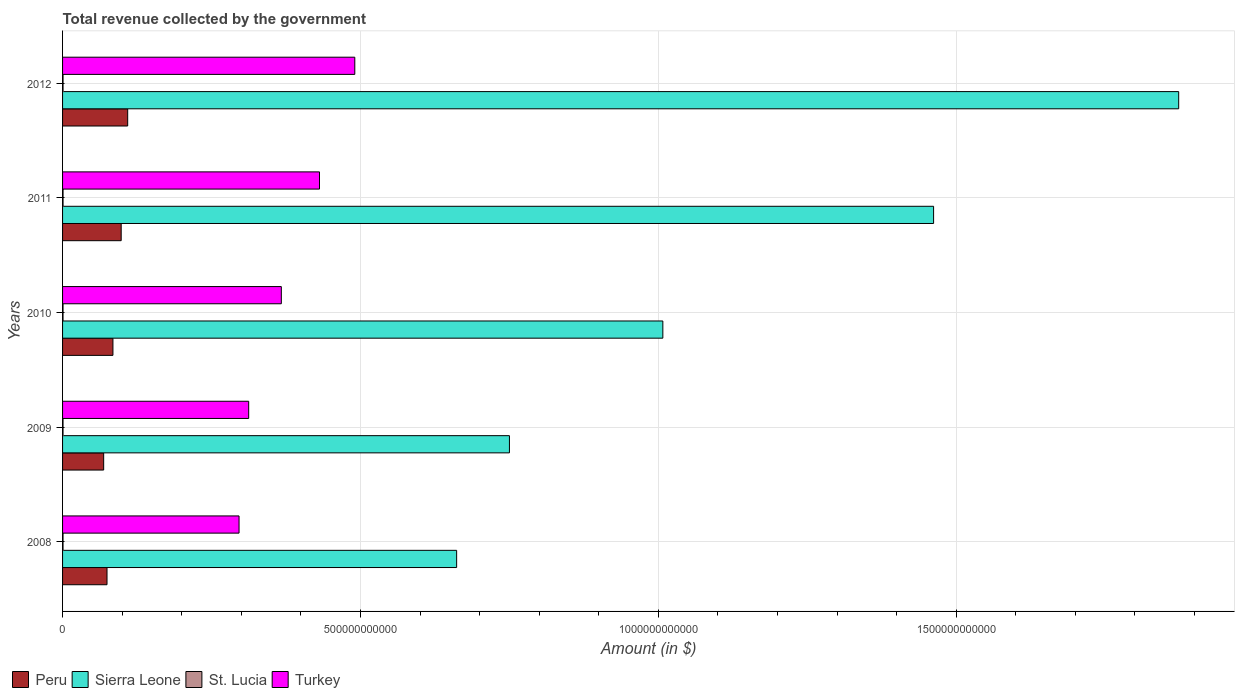How many groups of bars are there?
Your answer should be very brief. 5. Are the number of bars per tick equal to the number of legend labels?
Offer a terse response. Yes. Are the number of bars on each tick of the Y-axis equal?
Give a very brief answer. Yes. How many bars are there on the 4th tick from the top?
Offer a very short reply. 4. What is the label of the 4th group of bars from the top?
Provide a succinct answer. 2009. What is the total revenue collected by the government in Sierra Leone in 2011?
Your answer should be compact. 1.46e+12. Across all years, what is the maximum total revenue collected by the government in St. Lucia?
Make the answer very short. 8.17e+08. Across all years, what is the minimum total revenue collected by the government in Sierra Leone?
Offer a terse response. 6.61e+11. In which year was the total revenue collected by the government in Peru minimum?
Give a very brief answer. 2009. What is the total total revenue collected by the government in Sierra Leone in the graph?
Your answer should be compact. 5.75e+12. What is the difference between the total revenue collected by the government in Sierra Leone in 2008 and that in 2011?
Offer a terse response. -8.01e+11. What is the difference between the total revenue collected by the government in Turkey in 2010 and the total revenue collected by the government in Sierra Leone in 2008?
Give a very brief answer. -2.94e+11. What is the average total revenue collected by the government in Peru per year?
Offer a terse response. 8.72e+1. In the year 2008, what is the difference between the total revenue collected by the government in St. Lucia and total revenue collected by the government in Turkey?
Your answer should be compact. -2.95e+11. What is the ratio of the total revenue collected by the government in Peru in 2009 to that in 2011?
Ensure brevity in your answer.  0.7. Is the difference between the total revenue collected by the government in St. Lucia in 2009 and 2011 greater than the difference between the total revenue collected by the government in Turkey in 2009 and 2011?
Ensure brevity in your answer.  Yes. What is the difference between the highest and the second highest total revenue collected by the government in Peru?
Give a very brief answer. 1.09e+1. What is the difference between the highest and the lowest total revenue collected by the government in Peru?
Provide a short and direct response. 4.03e+1. What does the 3rd bar from the top in 2010 represents?
Offer a very short reply. Sierra Leone. How many bars are there?
Your answer should be very brief. 20. How many years are there in the graph?
Give a very brief answer. 5. What is the difference between two consecutive major ticks on the X-axis?
Provide a succinct answer. 5.00e+11. Does the graph contain any zero values?
Your response must be concise. No. Where does the legend appear in the graph?
Offer a very short reply. Bottom left. What is the title of the graph?
Offer a terse response. Total revenue collected by the government. Does "Vietnam" appear as one of the legend labels in the graph?
Provide a short and direct response. No. What is the label or title of the X-axis?
Provide a short and direct response. Amount (in $). What is the label or title of the Y-axis?
Your answer should be compact. Years. What is the Amount (in $) in Peru in 2008?
Provide a succinct answer. 7.46e+1. What is the Amount (in $) in Sierra Leone in 2008?
Keep it short and to the point. 6.61e+11. What is the Amount (in $) of St. Lucia in 2008?
Provide a succinct answer. 7.81e+08. What is the Amount (in $) of Turkey in 2008?
Provide a short and direct response. 2.96e+11. What is the Amount (in $) of Peru in 2009?
Your answer should be very brief. 6.90e+1. What is the Amount (in $) in Sierra Leone in 2009?
Make the answer very short. 7.50e+11. What is the Amount (in $) in St. Lucia in 2009?
Offer a terse response. 7.71e+08. What is the Amount (in $) of Turkey in 2009?
Offer a very short reply. 3.12e+11. What is the Amount (in $) of Peru in 2010?
Provide a short and direct response. 8.45e+1. What is the Amount (in $) of Sierra Leone in 2010?
Your response must be concise. 1.01e+12. What is the Amount (in $) of St. Lucia in 2010?
Give a very brief answer. 7.76e+08. What is the Amount (in $) in Turkey in 2010?
Make the answer very short. 3.67e+11. What is the Amount (in $) in Peru in 2011?
Ensure brevity in your answer.  9.84e+1. What is the Amount (in $) of Sierra Leone in 2011?
Your answer should be very brief. 1.46e+12. What is the Amount (in $) in St. Lucia in 2011?
Ensure brevity in your answer.  8.17e+08. What is the Amount (in $) of Turkey in 2011?
Provide a short and direct response. 4.31e+11. What is the Amount (in $) of Peru in 2012?
Keep it short and to the point. 1.09e+11. What is the Amount (in $) of Sierra Leone in 2012?
Your response must be concise. 1.87e+12. What is the Amount (in $) of St. Lucia in 2012?
Your response must be concise. 8.10e+08. What is the Amount (in $) of Turkey in 2012?
Offer a terse response. 4.91e+11. Across all years, what is the maximum Amount (in $) in Peru?
Ensure brevity in your answer.  1.09e+11. Across all years, what is the maximum Amount (in $) of Sierra Leone?
Give a very brief answer. 1.87e+12. Across all years, what is the maximum Amount (in $) in St. Lucia?
Give a very brief answer. 8.17e+08. Across all years, what is the maximum Amount (in $) of Turkey?
Ensure brevity in your answer.  4.91e+11. Across all years, what is the minimum Amount (in $) of Peru?
Ensure brevity in your answer.  6.90e+1. Across all years, what is the minimum Amount (in $) of Sierra Leone?
Ensure brevity in your answer.  6.61e+11. Across all years, what is the minimum Amount (in $) of St. Lucia?
Provide a succinct answer. 7.71e+08. Across all years, what is the minimum Amount (in $) in Turkey?
Keep it short and to the point. 2.96e+11. What is the total Amount (in $) in Peru in the graph?
Offer a very short reply. 4.36e+11. What is the total Amount (in $) of Sierra Leone in the graph?
Your answer should be very brief. 5.75e+12. What is the total Amount (in $) of St. Lucia in the graph?
Keep it short and to the point. 3.96e+09. What is the total Amount (in $) of Turkey in the graph?
Offer a terse response. 1.90e+12. What is the difference between the Amount (in $) of Peru in 2008 and that in 2009?
Ensure brevity in your answer.  5.60e+09. What is the difference between the Amount (in $) in Sierra Leone in 2008 and that in 2009?
Make the answer very short. -8.86e+1. What is the difference between the Amount (in $) in St. Lucia in 2008 and that in 2009?
Your response must be concise. 1.03e+07. What is the difference between the Amount (in $) of Turkey in 2008 and that in 2009?
Keep it short and to the point. -1.62e+1. What is the difference between the Amount (in $) of Peru in 2008 and that in 2010?
Your answer should be very brief. -9.94e+09. What is the difference between the Amount (in $) of Sierra Leone in 2008 and that in 2010?
Keep it short and to the point. -3.46e+11. What is the difference between the Amount (in $) of St. Lucia in 2008 and that in 2010?
Make the answer very short. 4.90e+06. What is the difference between the Amount (in $) in Turkey in 2008 and that in 2010?
Give a very brief answer. -7.10e+1. What is the difference between the Amount (in $) of Peru in 2008 and that in 2011?
Ensure brevity in your answer.  -2.38e+1. What is the difference between the Amount (in $) of Sierra Leone in 2008 and that in 2011?
Make the answer very short. -8.01e+11. What is the difference between the Amount (in $) of St. Lucia in 2008 and that in 2011?
Offer a very short reply. -3.54e+07. What is the difference between the Amount (in $) of Turkey in 2008 and that in 2011?
Give a very brief answer. -1.35e+11. What is the difference between the Amount (in $) of Peru in 2008 and that in 2012?
Offer a terse response. -3.47e+1. What is the difference between the Amount (in $) in Sierra Leone in 2008 and that in 2012?
Ensure brevity in your answer.  -1.21e+12. What is the difference between the Amount (in $) of St. Lucia in 2008 and that in 2012?
Your response must be concise. -2.92e+07. What is the difference between the Amount (in $) in Turkey in 2008 and that in 2012?
Ensure brevity in your answer.  -1.94e+11. What is the difference between the Amount (in $) of Peru in 2009 and that in 2010?
Offer a terse response. -1.55e+1. What is the difference between the Amount (in $) of Sierra Leone in 2009 and that in 2010?
Make the answer very short. -2.58e+11. What is the difference between the Amount (in $) in St. Lucia in 2009 and that in 2010?
Ensure brevity in your answer.  -5.40e+06. What is the difference between the Amount (in $) in Turkey in 2009 and that in 2010?
Make the answer very short. -5.48e+1. What is the difference between the Amount (in $) of Peru in 2009 and that in 2011?
Give a very brief answer. -2.94e+1. What is the difference between the Amount (in $) of Sierra Leone in 2009 and that in 2011?
Your answer should be very brief. -7.12e+11. What is the difference between the Amount (in $) of St. Lucia in 2009 and that in 2011?
Make the answer very short. -4.57e+07. What is the difference between the Amount (in $) of Turkey in 2009 and that in 2011?
Your answer should be compact. -1.19e+11. What is the difference between the Amount (in $) in Peru in 2009 and that in 2012?
Provide a short and direct response. -4.03e+1. What is the difference between the Amount (in $) of Sierra Leone in 2009 and that in 2012?
Keep it short and to the point. -1.12e+12. What is the difference between the Amount (in $) of St. Lucia in 2009 and that in 2012?
Make the answer very short. -3.95e+07. What is the difference between the Amount (in $) in Turkey in 2009 and that in 2012?
Offer a very short reply. -1.78e+11. What is the difference between the Amount (in $) of Peru in 2010 and that in 2011?
Provide a succinct answer. -1.39e+1. What is the difference between the Amount (in $) in Sierra Leone in 2010 and that in 2011?
Offer a terse response. -4.54e+11. What is the difference between the Amount (in $) in St. Lucia in 2010 and that in 2011?
Ensure brevity in your answer.  -4.03e+07. What is the difference between the Amount (in $) of Turkey in 2010 and that in 2011?
Ensure brevity in your answer.  -6.41e+1. What is the difference between the Amount (in $) in Peru in 2010 and that in 2012?
Ensure brevity in your answer.  -2.48e+1. What is the difference between the Amount (in $) in Sierra Leone in 2010 and that in 2012?
Provide a short and direct response. -8.66e+11. What is the difference between the Amount (in $) in St. Lucia in 2010 and that in 2012?
Provide a short and direct response. -3.41e+07. What is the difference between the Amount (in $) of Turkey in 2010 and that in 2012?
Provide a succinct answer. -1.23e+11. What is the difference between the Amount (in $) in Peru in 2011 and that in 2012?
Offer a terse response. -1.09e+1. What is the difference between the Amount (in $) in Sierra Leone in 2011 and that in 2012?
Provide a succinct answer. -4.11e+11. What is the difference between the Amount (in $) of St. Lucia in 2011 and that in 2012?
Ensure brevity in your answer.  6.20e+06. What is the difference between the Amount (in $) of Turkey in 2011 and that in 2012?
Keep it short and to the point. -5.93e+1. What is the difference between the Amount (in $) of Peru in 2008 and the Amount (in $) of Sierra Leone in 2009?
Provide a succinct answer. -6.76e+11. What is the difference between the Amount (in $) in Peru in 2008 and the Amount (in $) in St. Lucia in 2009?
Your response must be concise. 7.38e+1. What is the difference between the Amount (in $) of Peru in 2008 and the Amount (in $) of Turkey in 2009?
Your answer should be compact. -2.38e+11. What is the difference between the Amount (in $) in Sierra Leone in 2008 and the Amount (in $) in St. Lucia in 2009?
Offer a very short reply. 6.61e+11. What is the difference between the Amount (in $) in Sierra Leone in 2008 and the Amount (in $) in Turkey in 2009?
Your answer should be compact. 3.49e+11. What is the difference between the Amount (in $) of St. Lucia in 2008 and the Amount (in $) of Turkey in 2009?
Ensure brevity in your answer.  -3.12e+11. What is the difference between the Amount (in $) of Peru in 2008 and the Amount (in $) of Sierra Leone in 2010?
Your answer should be compact. -9.33e+11. What is the difference between the Amount (in $) of Peru in 2008 and the Amount (in $) of St. Lucia in 2010?
Make the answer very short. 7.38e+1. What is the difference between the Amount (in $) of Peru in 2008 and the Amount (in $) of Turkey in 2010?
Keep it short and to the point. -2.93e+11. What is the difference between the Amount (in $) of Sierra Leone in 2008 and the Amount (in $) of St. Lucia in 2010?
Provide a succinct answer. 6.61e+11. What is the difference between the Amount (in $) in Sierra Leone in 2008 and the Amount (in $) in Turkey in 2010?
Ensure brevity in your answer.  2.94e+11. What is the difference between the Amount (in $) in St. Lucia in 2008 and the Amount (in $) in Turkey in 2010?
Make the answer very short. -3.66e+11. What is the difference between the Amount (in $) of Peru in 2008 and the Amount (in $) of Sierra Leone in 2011?
Your answer should be very brief. -1.39e+12. What is the difference between the Amount (in $) of Peru in 2008 and the Amount (in $) of St. Lucia in 2011?
Your answer should be compact. 7.38e+1. What is the difference between the Amount (in $) of Peru in 2008 and the Amount (in $) of Turkey in 2011?
Offer a very short reply. -3.57e+11. What is the difference between the Amount (in $) of Sierra Leone in 2008 and the Amount (in $) of St. Lucia in 2011?
Provide a succinct answer. 6.61e+11. What is the difference between the Amount (in $) in Sierra Leone in 2008 and the Amount (in $) in Turkey in 2011?
Your response must be concise. 2.30e+11. What is the difference between the Amount (in $) of St. Lucia in 2008 and the Amount (in $) of Turkey in 2011?
Offer a terse response. -4.31e+11. What is the difference between the Amount (in $) in Peru in 2008 and the Amount (in $) in Sierra Leone in 2012?
Give a very brief answer. -1.80e+12. What is the difference between the Amount (in $) in Peru in 2008 and the Amount (in $) in St. Lucia in 2012?
Your answer should be compact. 7.38e+1. What is the difference between the Amount (in $) of Peru in 2008 and the Amount (in $) of Turkey in 2012?
Offer a terse response. -4.16e+11. What is the difference between the Amount (in $) in Sierra Leone in 2008 and the Amount (in $) in St. Lucia in 2012?
Ensure brevity in your answer.  6.61e+11. What is the difference between the Amount (in $) in Sierra Leone in 2008 and the Amount (in $) in Turkey in 2012?
Make the answer very short. 1.71e+11. What is the difference between the Amount (in $) of St. Lucia in 2008 and the Amount (in $) of Turkey in 2012?
Offer a very short reply. -4.90e+11. What is the difference between the Amount (in $) of Peru in 2009 and the Amount (in $) of Sierra Leone in 2010?
Offer a very short reply. -9.39e+11. What is the difference between the Amount (in $) of Peru in 2009 and the Amount (in $) of St. Lucia in 2010?
Make the answer very short. 6.82e+1. What is the difference between the Amount (in $) in Peru in 2009 and the Amount (in $) in Turkey in 2010?
Provide a succinct answer. -2.98e+11. What is the difference between the Amount (in $) of Sierra Leone in 2009 and the Amount (in $) of St. Lucia in 2010?
Offer a very short reply. 7.49e+11. What is the difference between the Amount (in $) of Sierra Leone in 2009 and the Amount (in $) of Turkey in 2010?
Provide a short and direct response. 3.83e+11. What is the difference between the Amount (in $) of St. Lucia in 2009 and the Amount (in $) of Turkey in 2010?
Ensure brevity in your answer.  -3.66e+11. What is the difference between the Amount (in $) of Peru in 2009 and the Amount (in $) of Sierra Leone in 2011?
Make the answer very short. -1.39e+12. What is the difference between the Amount (in $) of Peru in 2009 and the Amount (in $) of St. Lucia in 2011?
Provide a succinct answer. 6.82e+1. What is the difference between the Amount (in $) of Peru in 2009 and the Amount (in $) of Turkey in 2011?
Keep it short and to the point. -3.62e+11. What is the difference between the Amount (in $) in Sierra Leone in 2009 and the Amount (in $) in St. Lucia in 2011?
Offer a terse response. 7.49e+11. What is the difference between the Amount (in $) of Sierra Leone in 2009 and the Amount (in $) of Turkey in 2011?
Ensure brevity in your answer.  3.19e+11. What is the difference between the Amount (in $) in St. Lucia in 2009 and the Amount (in $) in Turkey in 2011?
Keep it short and to the point. -4.31e+11. What is the difference between the Amount (in $) in Peru in 2009 and the Amount (in $) in Sierra Leone in 2012?
Give a very brief answer. -1.80e+12. What is the difference between the Amount (in $) of Peru in 2009 and the Amount (in $) of St. Lucia in 2012?
Offer a very short reply. 6.82e+1. What is the difference between the Amount (in $) in Peru in 2009 and the Amount (in $) in Turkey in 2012?
Give a very brief answer. -4.22e+11. What is the difference between the Amount (in $) in Sierra Leone in 2009 and the Amount (in $) in St. Lucia in 2012?
Offer a terse response. 7.49e+11. What is the difference between the Amount (in $) of Sierra Leone in 2009 and the Amount (in $) of Turkey in 2012?
Give a very brief answer. 2.60e+11. What is the difference between the Amount (in $) in St. Lucia in 2009 and the Amount (in $) in Turkey in 2012?
Your response must be concise. -4.90e+11. What is the difference between the Amount (in $) of Peru in 2010 and the Amount (in $) of Sierra Leone in 2011?
Your answer should be compact. -1.38e+12. What is the difference between the Amount (in $) of Peru in 2010 and the Amount (in $) of St. Lucia in 2011?
Your response must be concise. 8.37e+1. What is the difference between the Amount (in $) of Peru in 2010 and the Amount (in $) of Turkey in 2011?
Offer a very short reply. -3.47e+11. What is the difference between the Amount (in $) of Sierra Leone in 2010 and the Amount (in $) of St. Lucia in 2011?
Offer a terse response. 1.01e+12. What is the difference between the Amount (in $) of Sierra Leone in 2010 and the Amount (in $) of Turkey in 2011?
Provide a succinct answer. 5.76e+11. What is the difference between the Amount (in $) in St. Lucia in 2010 and the Amount (in $) in Turkey in 2011?
Offer a very short reply. -4.31e+11. What is the difference between the Amount (in $) in Peru in 2010 and the Amount (in $) in Sierra Leone in 2012?
Make the answer very short. -1.79e+12. What is the difference between the Amount (in $) in Peru in 2010 and the Amount (in $) in St. Lucia in 2012?
Your answer should be compact. 8.37e+1. What is the difference between the Amount (in $) in Peru in 2010 and the Amount (in $) in Turkey in 2012?
Your answer should be compact. -4.06e+11. What is the difference between the Amount (in $) in Sierra Leone in 2010 and the Amount (in $) in St. Lucia in 2012?
Provide a succinct answer. 1.01e+12. What is the difference between the Amount (in $) in Sierra Leone in 2010 and the Amount (in $) in Turkey in 2012?
Make the answer very short. 5.17e+11. What is the difference between the Amount (in $) in St. Lucia in 2010 and the Amount (in $) in Turkey in 2012?
Your response must be concise. -4.90e+11. What is the difference between the Amount (in $) of Peru in 2011 and the Amount (in $) of Sierra Leone in 2012?
Provide a succinct answer. -1.78e+12. What is the difference between the Amount (in $) of Peru in 2011 and the Amount (in $) of St. Lucia in 2012?
Keep it short and to the point. 9.76e+1. What is the difference between the Amount (in $) in Peru in 2011 and the Amount (in $) in Turkey in 2012?
Offer a terse response. -3.92e+11. What is the difference between the Amount (in $) in Sierra Leone in 2011 and the Amount (in $) in St. Lucia in 2012?
Your answer should be compact. 1.46e+12. What is the difference between the Amount (in $) in Sierra Leone in 2011 and the Amount (in $) in Turkey in 2012?
Your answer should be very brief. 9.72e+11. What is the difference between the Amount (in $) of St. Lucia in 2011 and the Amount (in $) of Turkey in 2012?
Provide a succinct answer. -4.90e+11. What is the average Amount (in $) in Peru per year?
Offer a terse response. 8.72e+1. What is the average Amount (in $) of Sierra Leone per year?
Your response must be concise. 1.15e+12. What is the average Amount (in $) in St. Lucia per year?
Give a very brief answer. 7.91e+08. What is the average Amount (in $) in Turkey per year?
Provide a short and direct response. 3.80e+11. In the year 2008, what is the difference between the Amount (in $) of Peru and Amount (in $) of Sierra Leone?
Ensure brevity in your answer.  -5.87e+11. In the year 2008, what is the difference between the Amount (in $) of Peru and Amount (in $) of St. Lucia?
Offer a very short reply. 7.38e+1. In the year 2008, what is the difference between the Amount (in $) in Peru and Amount (in $) in Turkey?
Offer a terse response. -2.22e+11. In the year 2008, what is the difference between the Amount (in $) of Sierra Leone and Amount (in $) of St. Lucia?
Provide a short and direct response. 6.61e+11. In the year 2008, what is the difference between the Amount (in $) in Sierra Leone and Amount (in $) in Turkey?
Offer a very short reply. 3.65e+11. In the year 2008, what is the difference between the Amount (in $) in St. Lucia and Amount (in $) in Turkey?
Offer a terse response. -2.95e+11. In the year 2009, what is the difference between the Amount (in $) in Peru and Amount (in $) in Sierra Leone?
Your response must be concise. -6.81e+11. In the year 2009, what is the difference between the Amount (in $) of Peru and Amount (in $) of St. Lucia?
Your answer should be compact. 6.82e+1. In the year 2009, what is the difference between the Amount (in $) in Peru and Amount (in $) in Turkey?
Give a very brief answer. -2.43e+11. In the year 2009, what is the difference between the Amount (in $) in Sierra Leone and Amount (in $) in St. Lucia?
Your answer should be very brief. 7.49e+11. In the year 2009, what is the difference between the Amount (in $) in Sierra Leone and Amount (in $) in Turkey?
Offer a very short reply. 4.38e+11. In the year 2009, what is the difference between the Amount (in $) in St. Lucia and Amount (in $) in Turkey?
Your answer should be very brief. -3.12e+11. In the year 2010, what is the difference between the Amount (in $) of Peru and Amount (in $) of Sierra Leone?
Offer a terse response. -9.23e+11. In the year 2010, what is the difference between the Amount (in $) in Peru and Amount (in $) in St. Lucia?
Provide a short and direct response. 8.38e+1. In the year 2010, what is the difference between the Amount (in $) in Peru and Amount (in $) in Turkey?
Make the answer very short. -2.83e+11. In the year 2010, what is the difference between the Amount (in $) of Sierra Leone and Amount (in $) of St. Lucia?
Make the answer very short. 1.01e+12. In the year 2010, what is the difference between the Amount (in $) of Sierra Leone and Amount (in $) of Turkey?
Your response must be concise. 6.40e+11. In the year 2010, what is the difference between the Amount (in $) of St. Lucia and Amount (in $) of Turkey?
Offer a very short reply. -3.66e+11. In the year 2011, what is the difference between the Amount (in $) in Peru and Amount (in $) in Sierra Leone?
Provide a short and direct response. -1.36e+12. In the year 2011, what is the difference between the Amount (in $) in Peru and Amount (in $) in St. Lucia?
Offer a terse response. 9.76e+1. In the year 2011, what is the difference between the Amount (in $) in Peru and Amount (in $) in Turkey?
Offer a very short reply. -3.33e+11. In the year 2011, what is the difference between the Amount (in $) of Sierra Leone and Amount (in $) of St. Lucia?
Provide a succinct answer. 1.46e+12. In the year 2011, what is the difference between the Amount (in $) of Sierra Leone and Amount (in $) of Turkey?
Keep it short and to the point. 1.03e+12. In the year 2011, what is the difference between the Amount (in $) in St. Lucia and Amount (in $) in Turkey?
Ensure brevity in your answer.  -4.30e+11. In the year 2012, what is the difference between the Amount (in $) of Peru and Amount (in $) of Sierra Leone?
Your answer should be very brief. -1.76e+12. In the year 2012, what is the difference between the Amount (in $) of Peru and Amount (in $) of St. Lucia?
Make the answer very short. 1.09e+11. In the year 2012, what is the difference between the Amount (in $) in Peru and Amount (in $) in Turkey?
Your answer should be very brief. -3.81e+11. In the year 2012, what is the difference between the Amount (in $) in Sierra Leone and Amount (in $) in St. Lucia?
Give a very brief answer. 1.87e+12. In the year 2012, what is the difference between the Amount (in $) in Sierra Leone and Amount (in $) in Turkey?
Offer a very short reply. 1.38e+12. In the year 2012, what is the difference between the Amount (in $) in St. Lucia and Amount (in $) in Turkey?
Keep it short and to the point. -4.90e+11. What is the ratio of the Amount (in $) of Peru in 2008 to that in 2009?
Your response must be concise. 1.08. What is the ratio of the Amount (in $) of Sierra Leone in 2008 to that in 2009?
Provide a succinct answer. 0.88. What is the ratio of the Amount (in $) in St. Lucia in 2008 to that in 2009?
Provide a succinct answer. 1.01. What is the ratio of the Amount (in $) of Turkey in 2008 to that in 2009?
Provide a succinct answer. 0.95. What is the ratio of the Amount (in $) of Peru in 2008 to that in 2010?
Keep it short and to the point. 0.88. What is the ratio of the Amount (in $) of Sierra Leone in 2008 to that in 2010?
Offer a very short reply. 0.66. What is the ratio of the Amount (in $) in Turkey in 2008 to that in 2010?
Make the answer very short. 0.81. What is the ratio of the Amount (in $) in Peru in 2008 to that in 2011?
Your response must be concise. 0.76. What is the ratio of the Amount (in $) of Sierra Leone in 2008 to that in 2011?
Offer a terse response. 0.45. What is the ratio of the Amount (in $) in St. Lucia in 2008 to that in 2011?
Keep it short and to the point. 0.96. What is the ratio of the Amount (in $) of Turkey in 2008 to that in 2011?
Your answer should be compact. 0.69. What is the ratio of the Amount (in $) of Peru in 2008 to that in 2012?
Ensure brevity in your answer.  0.68. What is the ratio of the Amount (in $) of Sierra Leone in 2008 to that in 2012?
Offer a terse response. 0.35. What is the ratio of the Amount (in $) of St. Lucia in 2008 to that in 2012?
Your response must be concise. 0.96. What is the ratio of the Amount (in $) in Turkey in 2008 to that in 2012?
Give a very brief answer. 0.6. What is the ratio of the Amount (in $) in Peru in 2009 to that in 2010?
Offer a very short reply. 0.82. What is the ratio of the Amount (in $) of Sierra Leone in 2009 to that in 2010?
Your response must be concise. 0.74. What is the ratio of the Amount (in $) in St. Lucia in 2009 to that in 2010?
Your response must be concise. 0.99. What is the ratio of the Amount (in $) in Turkey in 2009 to that in 2010?
Your response must be concise. 0.85. What is the ratio of the Amount (in $) in Peru in 2009 to that in 2011?
Give a very brief answer. 0.7. What is the ratio of the Amount (in $) in Sierra Leone in 2009 to that in 2011?
Your response must be concise. 0.51. What is the ratio of the Amount (in $) of St. Lucia in 2009 to that in 2011?
Offer a terse response. 0.94. What is the ratio of the Amount (in $) in Turkey in 2009 to that in 2011?
Your answer should be compact. 0.72. What is the ratio of the Amount (in $) of Peru in 2009 to that in 2012?
Provide a succinct answer. 0.63. What is the ratio of the Amount (in $) in Sierra Leone in 2009 to that in 2012?
Your answer should be very brief. 0.4. What is the ratio of the Amount (in $) in St. Lucia in 2009 to that in 2012?
Your response must be concise. 0.95. What is the ratio of the Amount (in $) of Turkey in 2009 to that in 2012?
Your answer should be compact. 0.64. What is the ratio of the Amount (in $) in Peru in 2010 to that in 2011?
Give a very brief answer. 0.86. What is the ratio of the Amount (in $) in Sierra Leone in 2010 to that in 2011?
Provide a succinct answer. 0.69. What is the ratio of the Amount (in $) of St. Lucia in 2010 to that in 2011?
Your answer should be very brief. 0.95. What is the ratio of the Amount (in $) in Turkey in 2010 to that in 2011?
Your answer should be compact. 0.85. What is the ratio of the Amount (in $) in Peru in 2010 to that in 2012?
Your answer should be very brief. 0.77. What is the ratio of the Amount (in $) in Sierra Leone in 2010 to that in 2012?
Give a very brief answer. 0.54. What is the ratio of the Amount (in $) in St. Lucia in 2010 to that in 2012?
Offer a very short reply. 0.96. What is the ratio of the Amount (in $) in Turkey in 2010 to that in 2012?
Your response must be concise. 0.75. What is the ratio of the Amount (in $) in Peru in 2011 to that in 2012?
Keep it short and to the point. 0.9. What is the ratio of the Amount (in $) in Sierra Leone in 2011 to that in 2012?
Give a very brief answer. 0.78. What is the ratio of the Amount (in $) of St. Lucia in 2011 to that in 2012?
Your answer should be very brief. 1.01. What is the ratio of the Amount (in $) in Turkey in 2011 to that in 2012?
Your answer should be very brief. 0.88. What is the difference between the highest and the second highest Amount (in $) of Peru?
Ensure brevity in your answer.  1.09e+1. What is the difference between the highest and the second highest Amount (in $) in Sierra Leone?
Keep it short and to the point. 4.11e+11. What is the difference between the highest and the second highest Amount (in $) of St. Lucia?
Provide a short and direct response. 6.20e+06. What is the difference between the highest and the second highest Amount (in $) of Turkey?
Give a very brief answer. 5.93e+1. What is the difference between the highest and the lowest Amount (in $) of Peru?
Give a very brief answer. 4.03e+1. What is the difference between the highest and the lowest Amount (in $) in Sierra Leone?
Ensure brevity in your answer.  1.21e+12. What is the difference between the highest and the lowest Amount (in $) of St. Lucia?
Provide a short and direct response. 4.57e+07. What is the difference between the highest and the lowest Amount (in $) in Turkey?
Provide a short and direct response. 1.94e+11. 